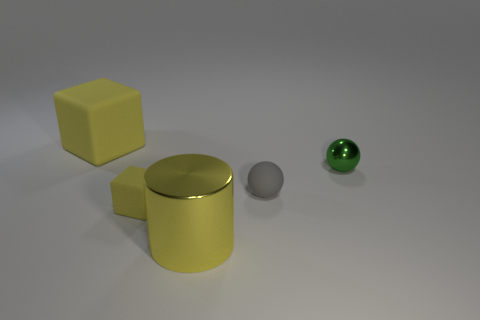Add 3 balls. How many objects exist? 8 Subtract all spheres. How many objects are left? 3 Subtract 1 spheres. How many spheres are left? 1 Subtract all big objects. Subtract all large blue matte objects. How many objects are left? 3 Add 2 yellow metallic objects. How many yellow metallic objects are left? 3 Add 1 big shiny cubes. How many big shiny cubes exist? 1 Subtract 0 yellow balls. How many objects are left? 5 Subtract all cyan blocks. Subtract all green spheres. How many blocks are left? 2 